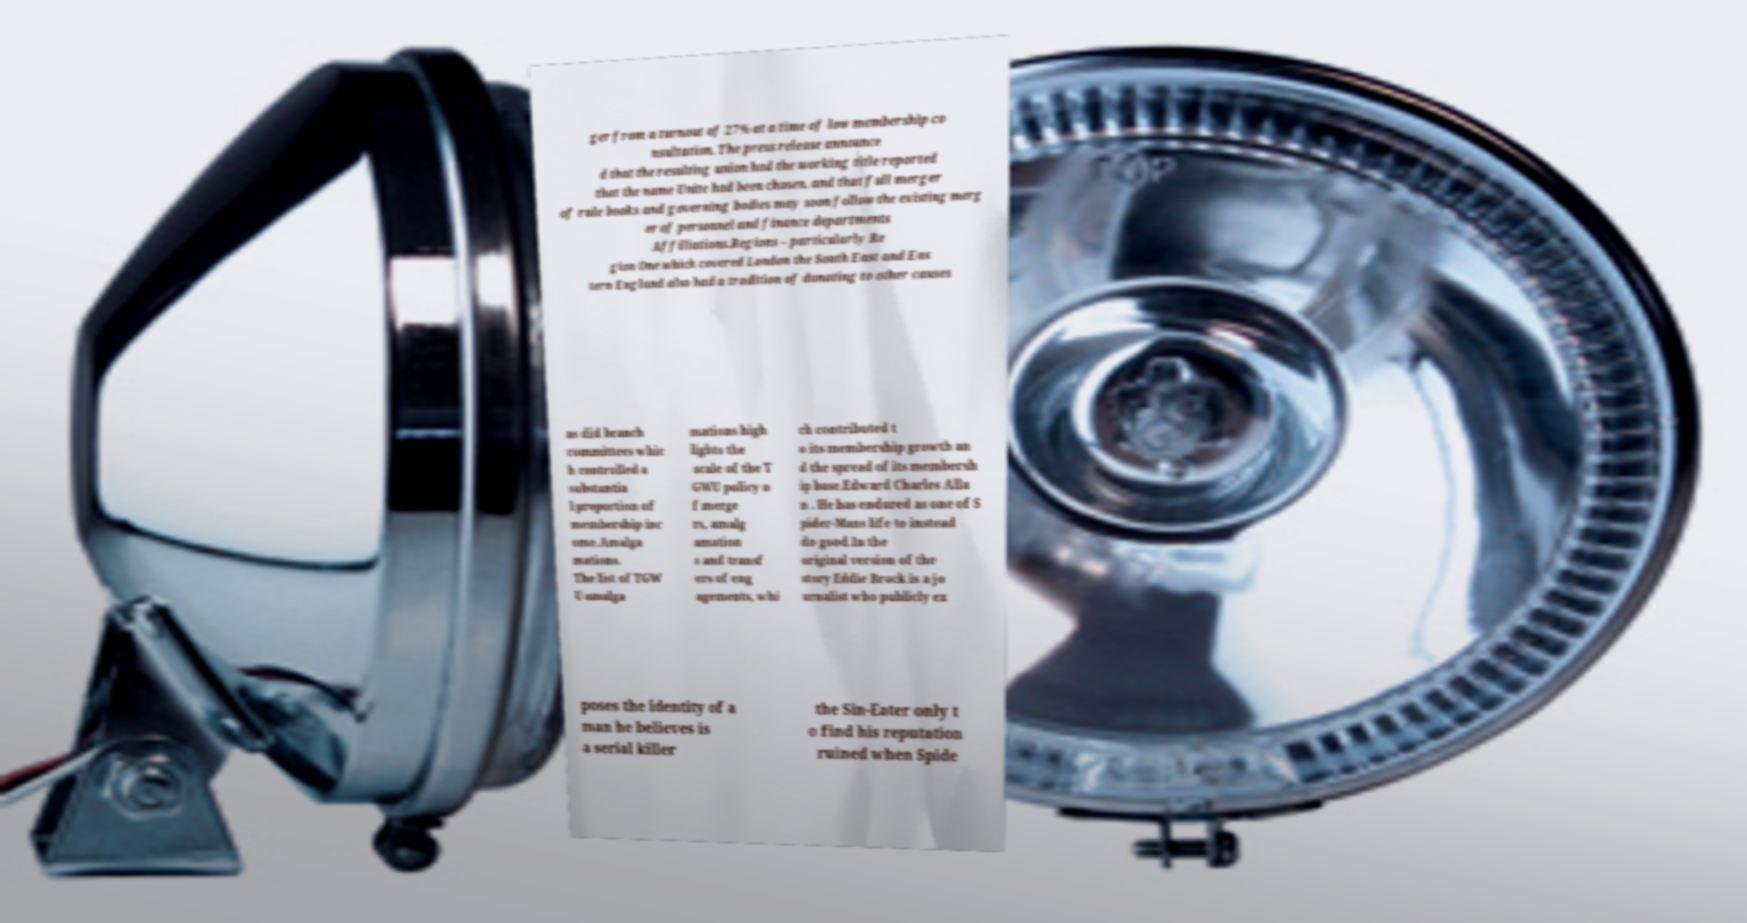There's text embedded in this image that I need extracted. Can you transcribe it verbatim? ger from a turnout of 27% at a time of low membership co nsultation. The press release announce d that the resulting union had the working title reported that the name Unite had been chosen. and that full merger of rule books and governing bodies may soon follow the existing merg er of personnel and finance departments Affiliations.Regions – particularly Re gion One which covered London the South East and Eas tern England also had a tradition of donating to other causes as did branch committees whic h controlled a substantia l proportion of membership inc ome.Amalga mations. The list of TGW U amalga mations high lights the scale of the T GWU policy o f merge rs, amalg amation s and transf ers of eng agements, whi ch contributed t o its membership growth an d the spread of its membersh ip base.Edward Charles Alla n . He has endured as one of S pider-Mans life to instead do good.In the original version of the story Eddie Brock is a jo urnalist who publicly ex poses the identity of a man he believes is a serial killer the Sin-Eater only t o find his reputation ruined when Spide 